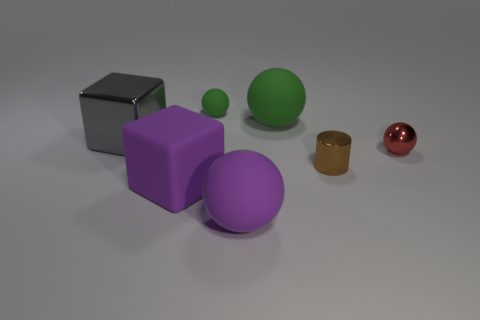Add 3 small matte spheres. How many objects exist? 10 Subtract all cubes. How many objects are left? 5 Add 5 matte balls. How many matte balls exist? 8 Subtract 0 cyan cylinders. How many objects are left? 7 Subtract all large purple things. Subtract all yellow matte cubes. How many objects are left? 5 Add 7 tiny green objects. How many tiny green objects are left? 8 